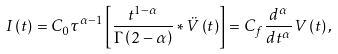<formula> <loc_0><loc_0><loc_500><loc_500>I \left ( t \right ) = C _ { 0 } \tau ^ { \alpha - 1 } \left [ \frac { t ^ { 1 - \alpha } } { \Gamma \left ( 2 - \alpha \right ) } \ast \ddot { V } \left ( t \right ) \right ] = C _ { f } \frac { d ^ { \alpha } } { d t ^ { \alpha } } V \left ( t \right ) ,</formula> 